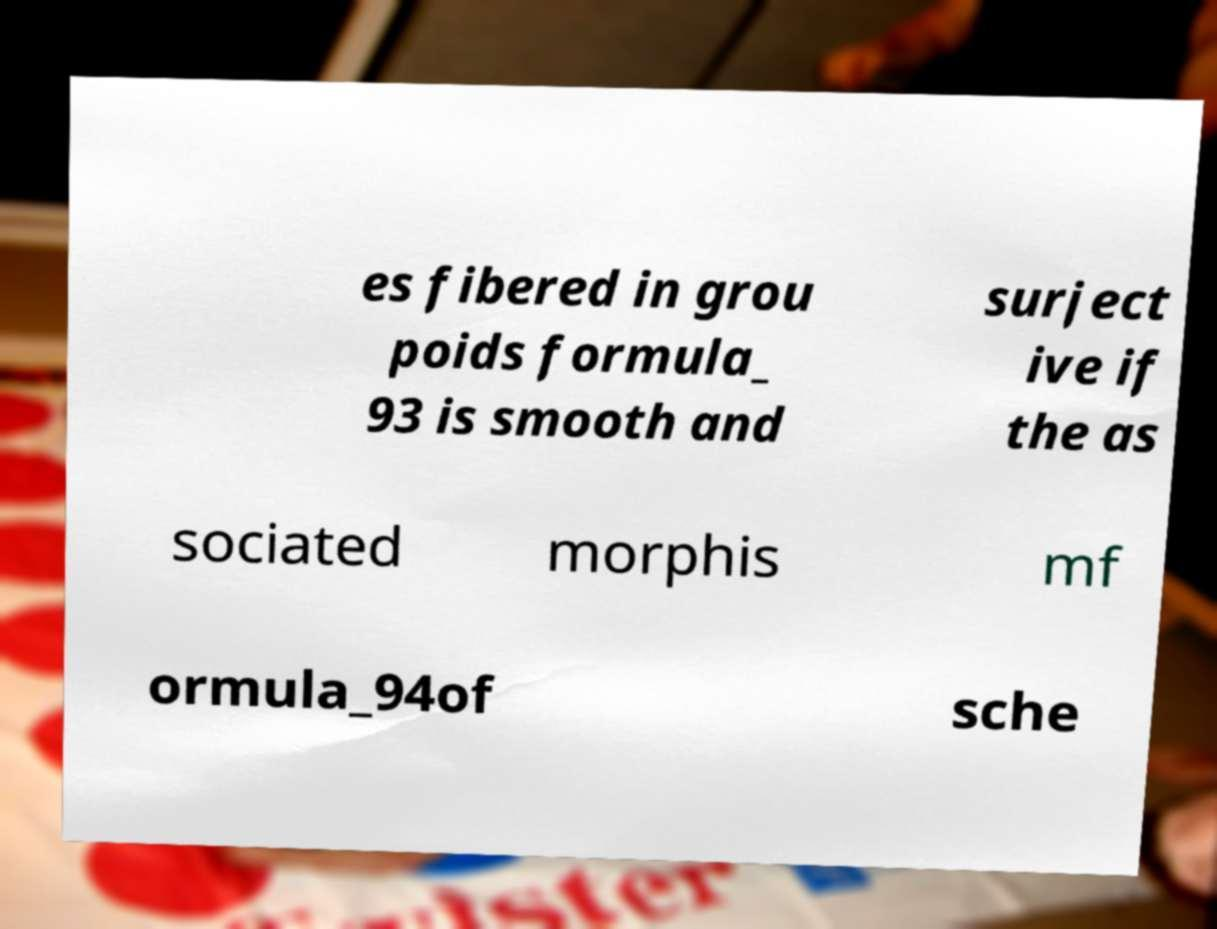Could you extract and type out the text from this image? es fibered in grou poids formula_ 93 is smooth and surject ive if the as sociated morphis mf ormula_94of sche 